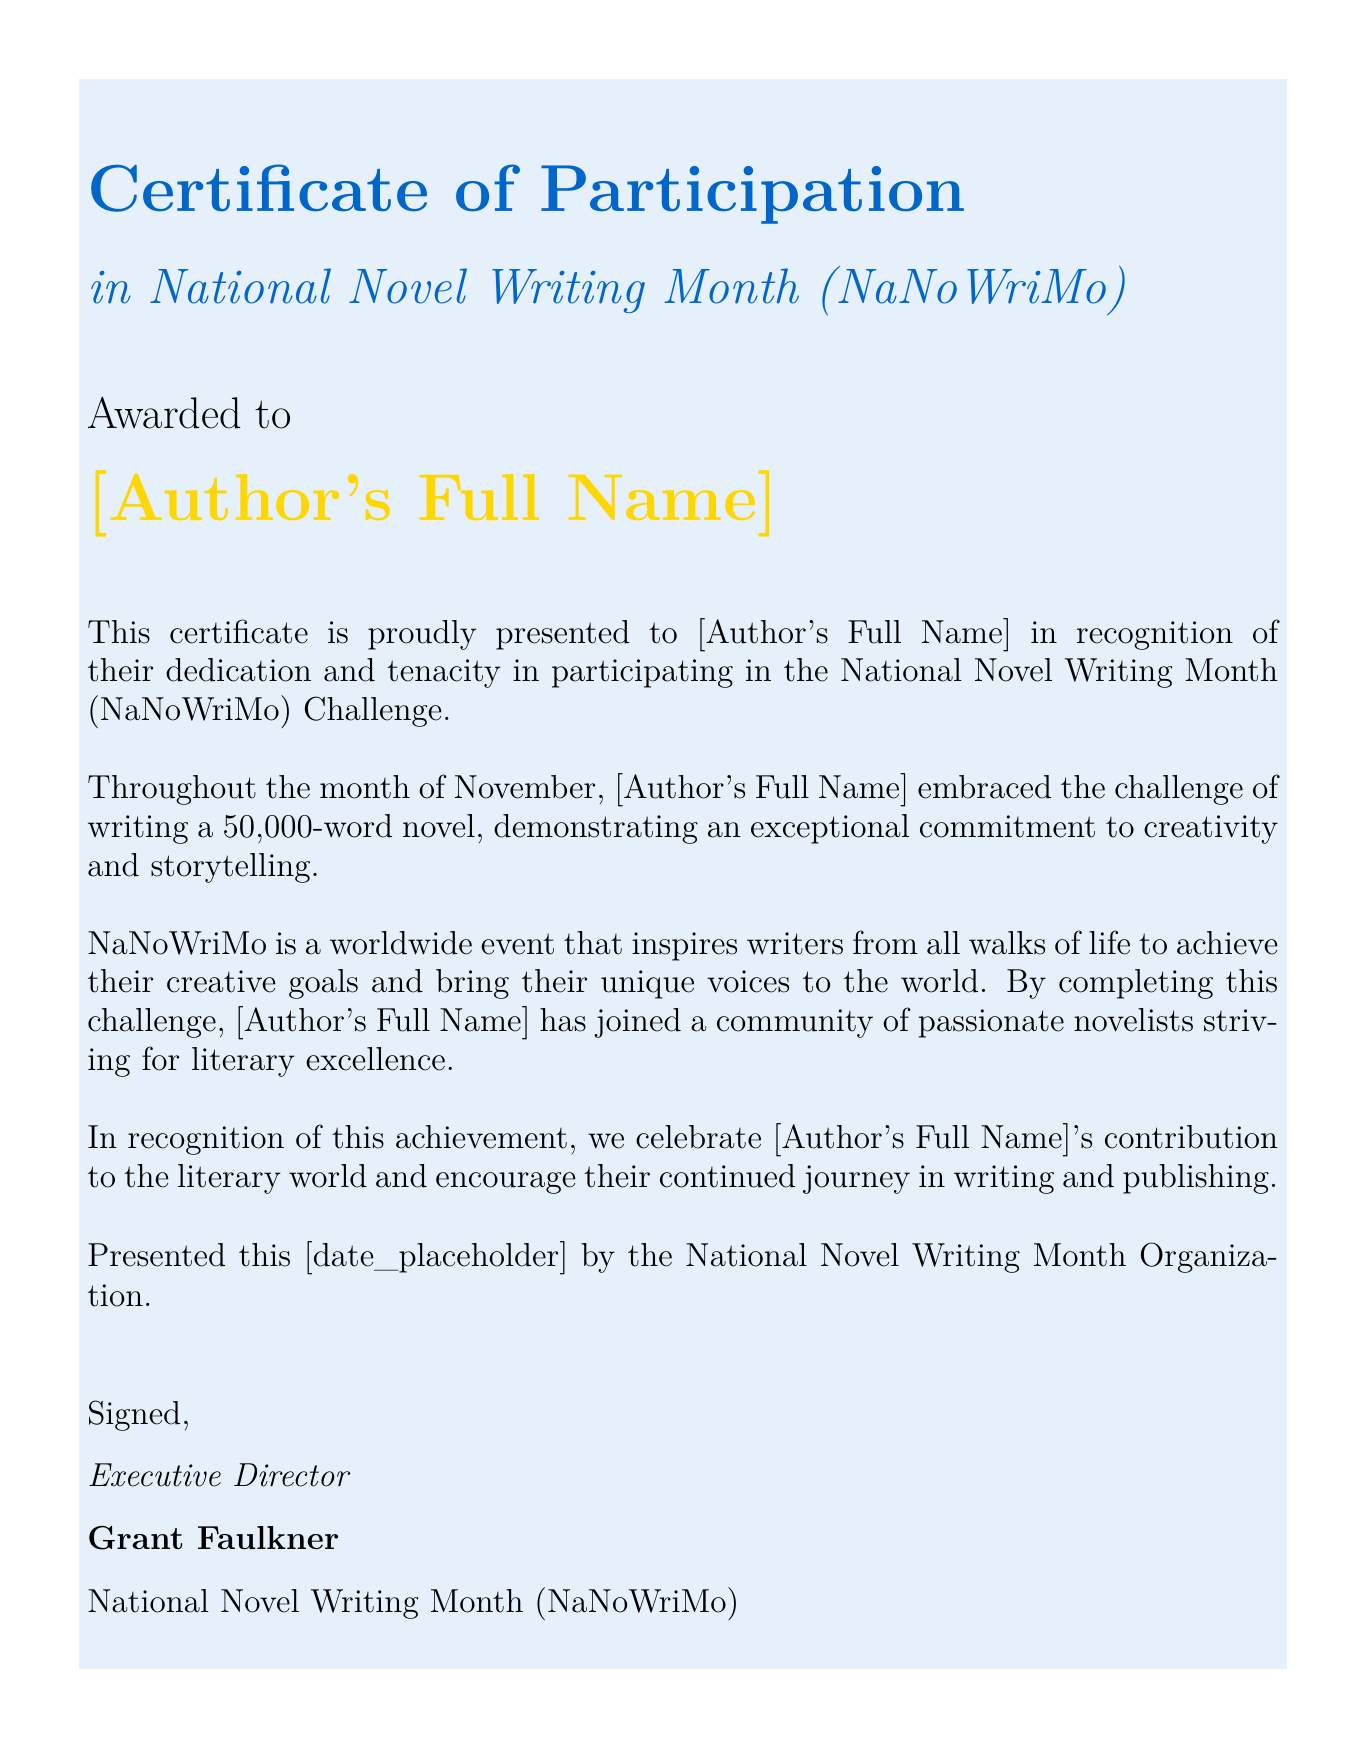What is the title of the certificate? The title of the certificate is the main heading presented at the top of the document.
Answer: Certificate of Participation Who is the certificate awarded to? The specific individual the certificate is addressed to is indicated in a prominent section of the document.
Answer: [Author's Full Name] What event does this certificate recognize participation in? The document explicitly states which event the participation is for in the subtitle.
Answer: National Novel Writing Month (NaNoWriMo) What is the word count challenge mentioned in the document? The document outlines the specific writing goal for NaNoWriMo participants.
Answer: 50,000-word novel Who signed the certificate? The document specifies the name of the individual who signed the certificate as part of the official endorsement.
Answer: Grant Faulkner What is the organizational role of the signer? The signer’s title is provided underneath their name, indicating their position within the organization.
Answer: Executive Director What is the color of the certificate title? The color used for the title of the certificate is mentioned in the description of the document's design.
Answer: novelblue On what date is this certificate presented? The document includes a placeholder for a specific date, indicating when the certificate is awarded.
Answer: [date_placeholder] 